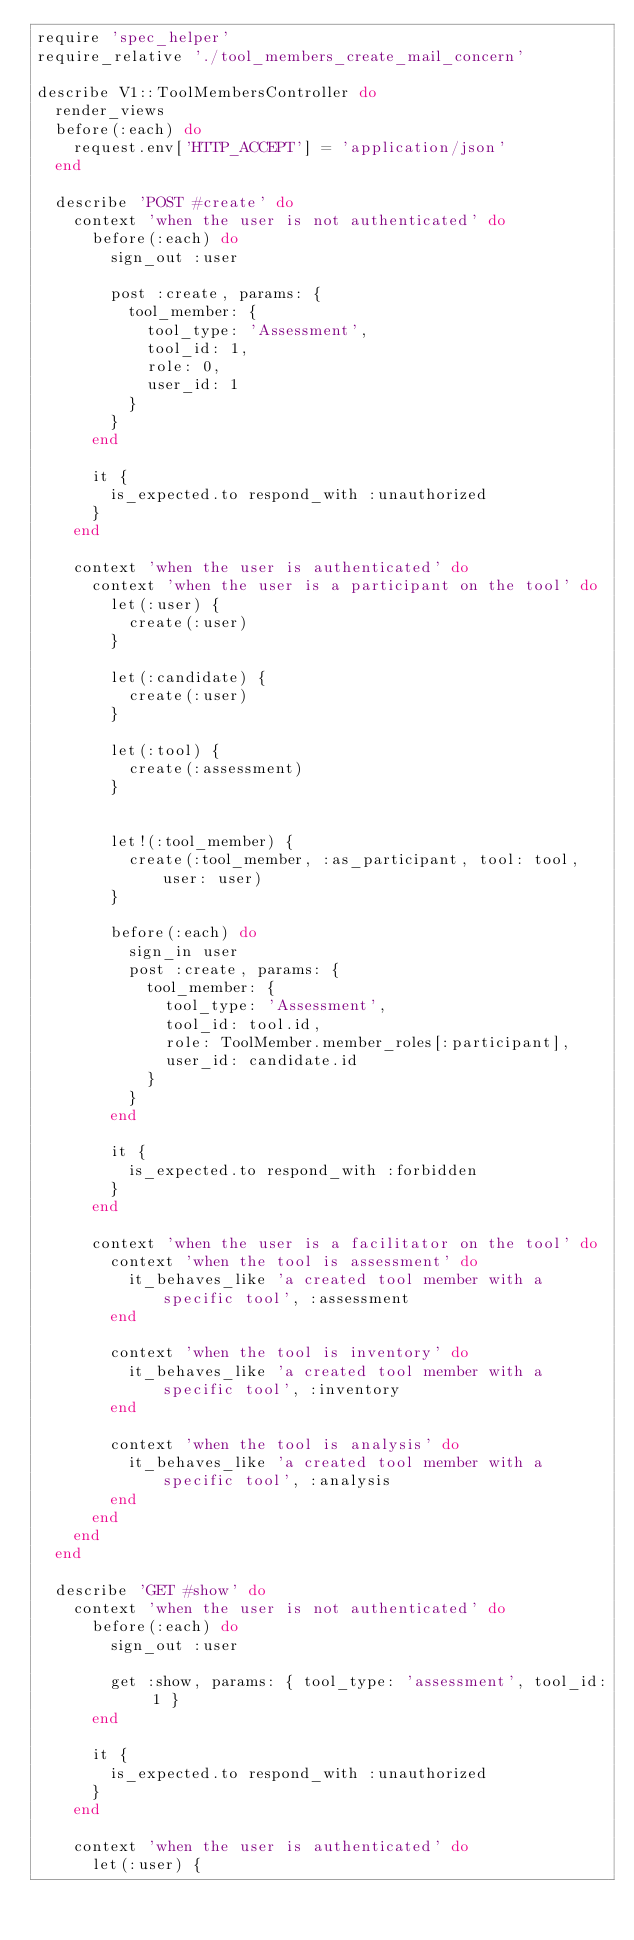<code> <loc_0><loc_0><loc_500><loc_500><_Ruby_>require 'spec_helper'
require_relative './tool_members_create_mail_concern'

describe V1::ToolMembersController do
  render_views
  before(:each) do
    request.env['HTTP_ACCEPT'] = 'application/json'
  end

  describe 'POST #create' do
    context 'when the user is not authenticated' do
      before(:each) do
        sign_out :user

        post :create, params: {
          tool_member: {
            tool_type: 'Assessment',
            tool_id: 1,
            role: 0,
            user_id: 1
          }
        }
      end

      it {
        is_expected.to respond_with :unauthorized
      }
    end

    context 'when the user is authenticated' do
      context 'when the user is a participant on the tool' do
        let(:user) {
          create(:user)
        }

        let(:candidate) {
          create(:user)
        }

        let(:tool) {
          create(:assessment)
        }


        let!(:tool_member) {
          create(:tool_member, :as_participant, tool: tool, user: user)
        }

        before(:each) do
          sign_in user
          post :create, params: {
            tool_member: {
              tool_type: 'Assessment',
              tool_id: tool.id,
              role: ToolMember.member_roles[:participant],
              user_id: candidate.id
            }
          }
        end

        it {
          is_expected.to respond_with :forbidden
        }
      end

      context 'when the user is a facilitator on the tool' do
        context 'when the tool is assessment' do
          it_behaves_like 'a created tool member with a specific tool', :assessment
        end

        context 'when the tool is inventory' do
          it_behaves_like 'a created tool member with a specific tool', :inventory
        end

        context 'when the tool is analysis' do
          it_behaves_like 'a created tool member with a specific tool', :analysis
        end
      end
    end
  end

  describe 'GET #show' do
    context 'when the user is not authenticated' do
      before(:each) do
        sign_out :user

        get :show, params: { tool_type: 'assessment', tool_id: 1 }
      end

      it {
        is_expected.to respond_with :unauthorized
      }
    end

    context 'when the user is authenticated' do
      let(:user) {</code> 